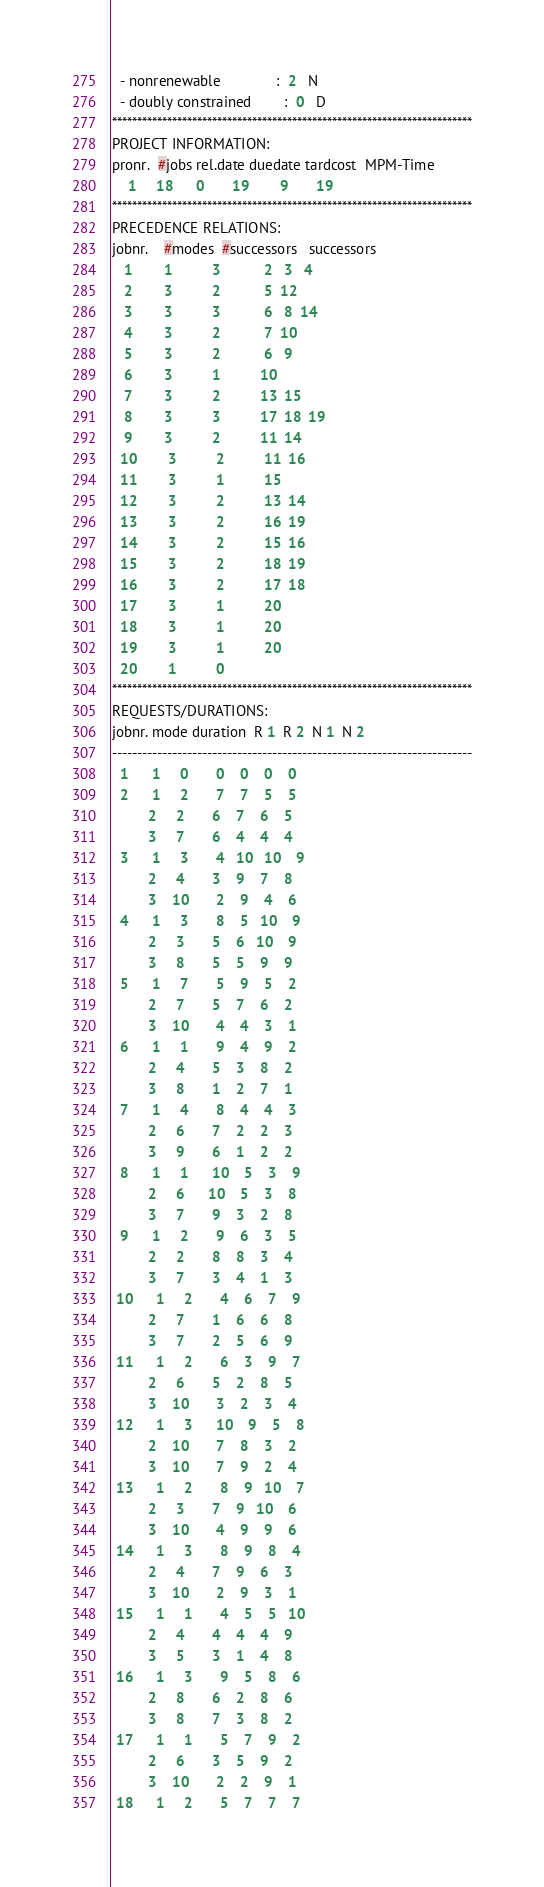<code> <loc_0><loc_0><loc_500><loc_500><_ObjectiveC_>  - nonrenewable              :  2   N
  - doubly constrained        :  0   D
************************************************************************
PROJECT INFORMATION:
pronr.  #jobs rel.date duedate tardcost  MPM-Time
    1     18      0       19        9       19
************************************************************************
PRECEDENCE RELATIONS:
jobnr.    #modes  #successors   successors
   1        1          3           2   3   4
   2        3          2           5  12
   3        3          3           6   8  14
   4        3          2           7  10
   5        3          2           6   9
   6        3          1          10
   7        3          2          13  15
   8        3          3          17  18  19
   9        3          2          11  14
  10        3          2          11  16
  11        3          1          15
  12        3          2          13  14
  13        3          2          16  19
  14        3          2          15  16
  15        3          2          18  19
  16        3          2          17  18
  17        3          1          20
  18        3          1          20
  19        3          1          20
  20        1          0        
************************************************************************
REQUESTS/DURATIONS:
jobnr. mode duration  R 1  R 2  N 1  N 2
------------------------------------------------------------------------
  1      1     0       0    0    0    0
  2      1     2       7    7    5    5
         2     2       6    7    6    5
         3     7       6    4    4    4
  3      1     3       4   10   10    9
         2     4       3    9    7    8
         3    10       2    9    4    6
  4      1     3       8    5   10    9
         2     3       5    6   10    9
         3     8       5    5    9    9
  5      1     7       5    9    5    2
         2     7       5    7    6    2
         3    10       4    4    3    1
  6      1     1       9    4    9    2
         2     4       5    3    8    2
         3     8       1    2    7    1
  7      1     4       8    4    4    3
         2     6       7    2    2    3
         3     9       6    1    2    2
  8      1     1      10    5    3    9
         2     6      10    5    3    8
         3     7       9    3    2    8
  9      1     2       9    6    3    5
         2     2       8    8    3    4
         3     7       3    4    1    3
 10      1     2       4    6    7    9
         2     7       1    6    6    8
         3     7       2    5    6    9
 11      1     2       6    3    9    7
         2     6       5    2    8    5
         3    10       3    2    3    4
 12      1     3      10    9    5    8
         2    10       7    8    3    2
         3    10       7    9    2    4
 13      1     2       8    9   10    7
         2     3       7    9   10    6
         3    10       4    9    9    6
 14      1     3       8    9    8    4
         2     4       7    9    6    3
         3    10       2    9    3    1
 15      1     1       4    5    5   10
         2     4       4    4    4    9
         3     5       3    1    4    8
 16      1     3       9    5    8    6
         2     8       6    2    8    6
         3     8       7    3    8    2
 17      1     1       5    7    9    2
         2     6       3    5    9    2
         3    10       2    2    9    1
 18      1     2       5    7    7    7</code> 